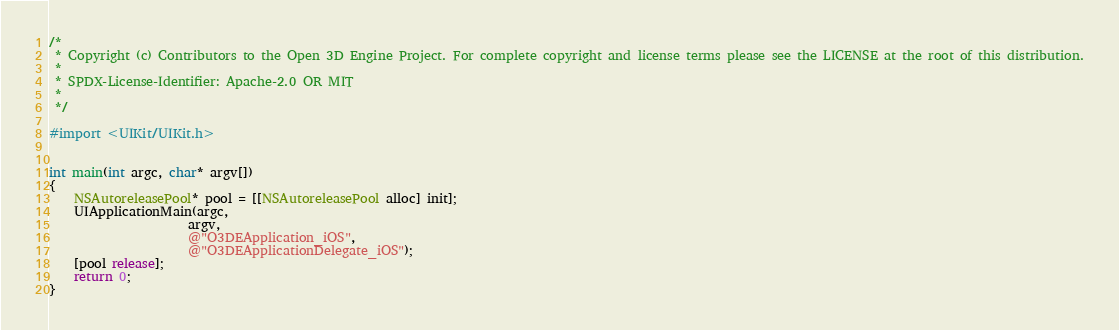Convert code to text. <code><loc_0><loc_0><loc_500><loc_500><_ObjectiveC_>/*
 * Copyright (c) Contributors to the Open 3D Engine Project. For complete copyright and license terms please see the LICENSE at the root of this distribution.
 * 
 * SPDX-License-Identifier: Apache-2.0 OR MIT
 *
 */

#import <UIKit/UIKit.h>


int main(int argc, char* argv[])
{
    NSAutoreleasePool* pool = [[NSAutoreleasePool alloc] init];
    UIApplicationMain(argc,
                      argv,
                      @"O3DEApplication_iOS",
                      @"O3DEApplicationDelegate_iOS");
    [pool release];
    return 0;
}
</code> 